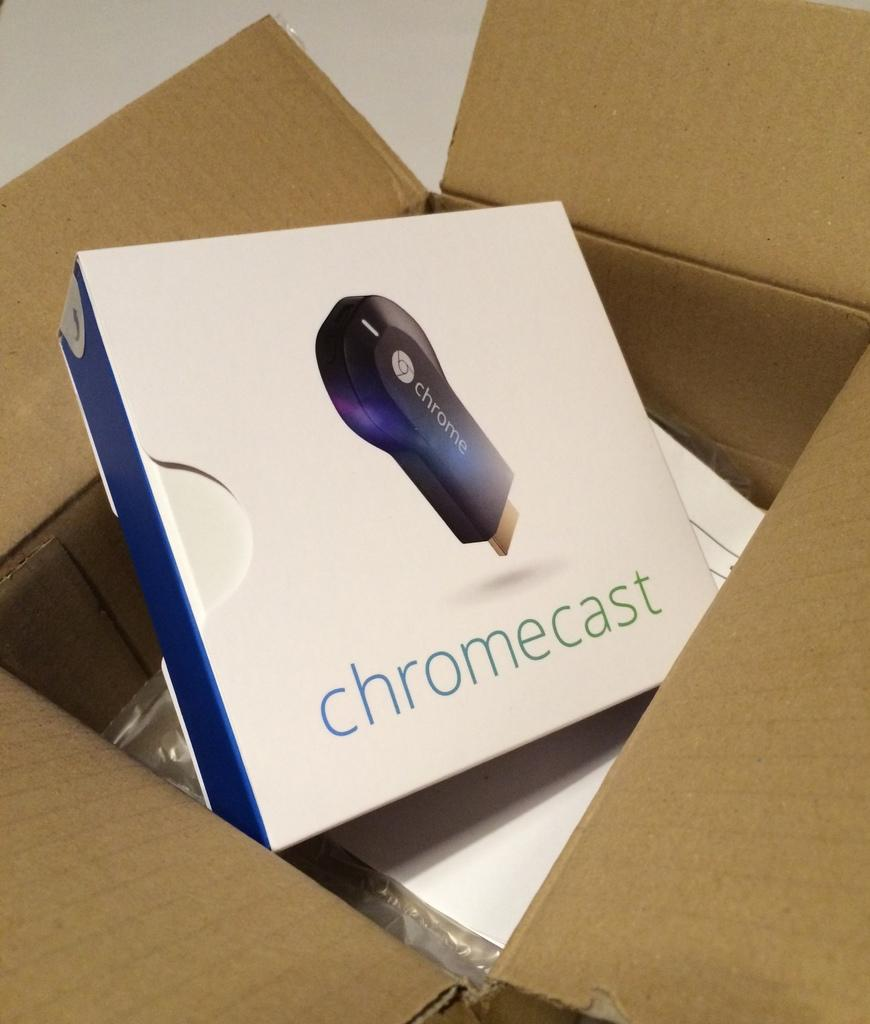<image>
Give a short and clear explanation of the subsequent image. an open box shows a box from Chrome Cast 